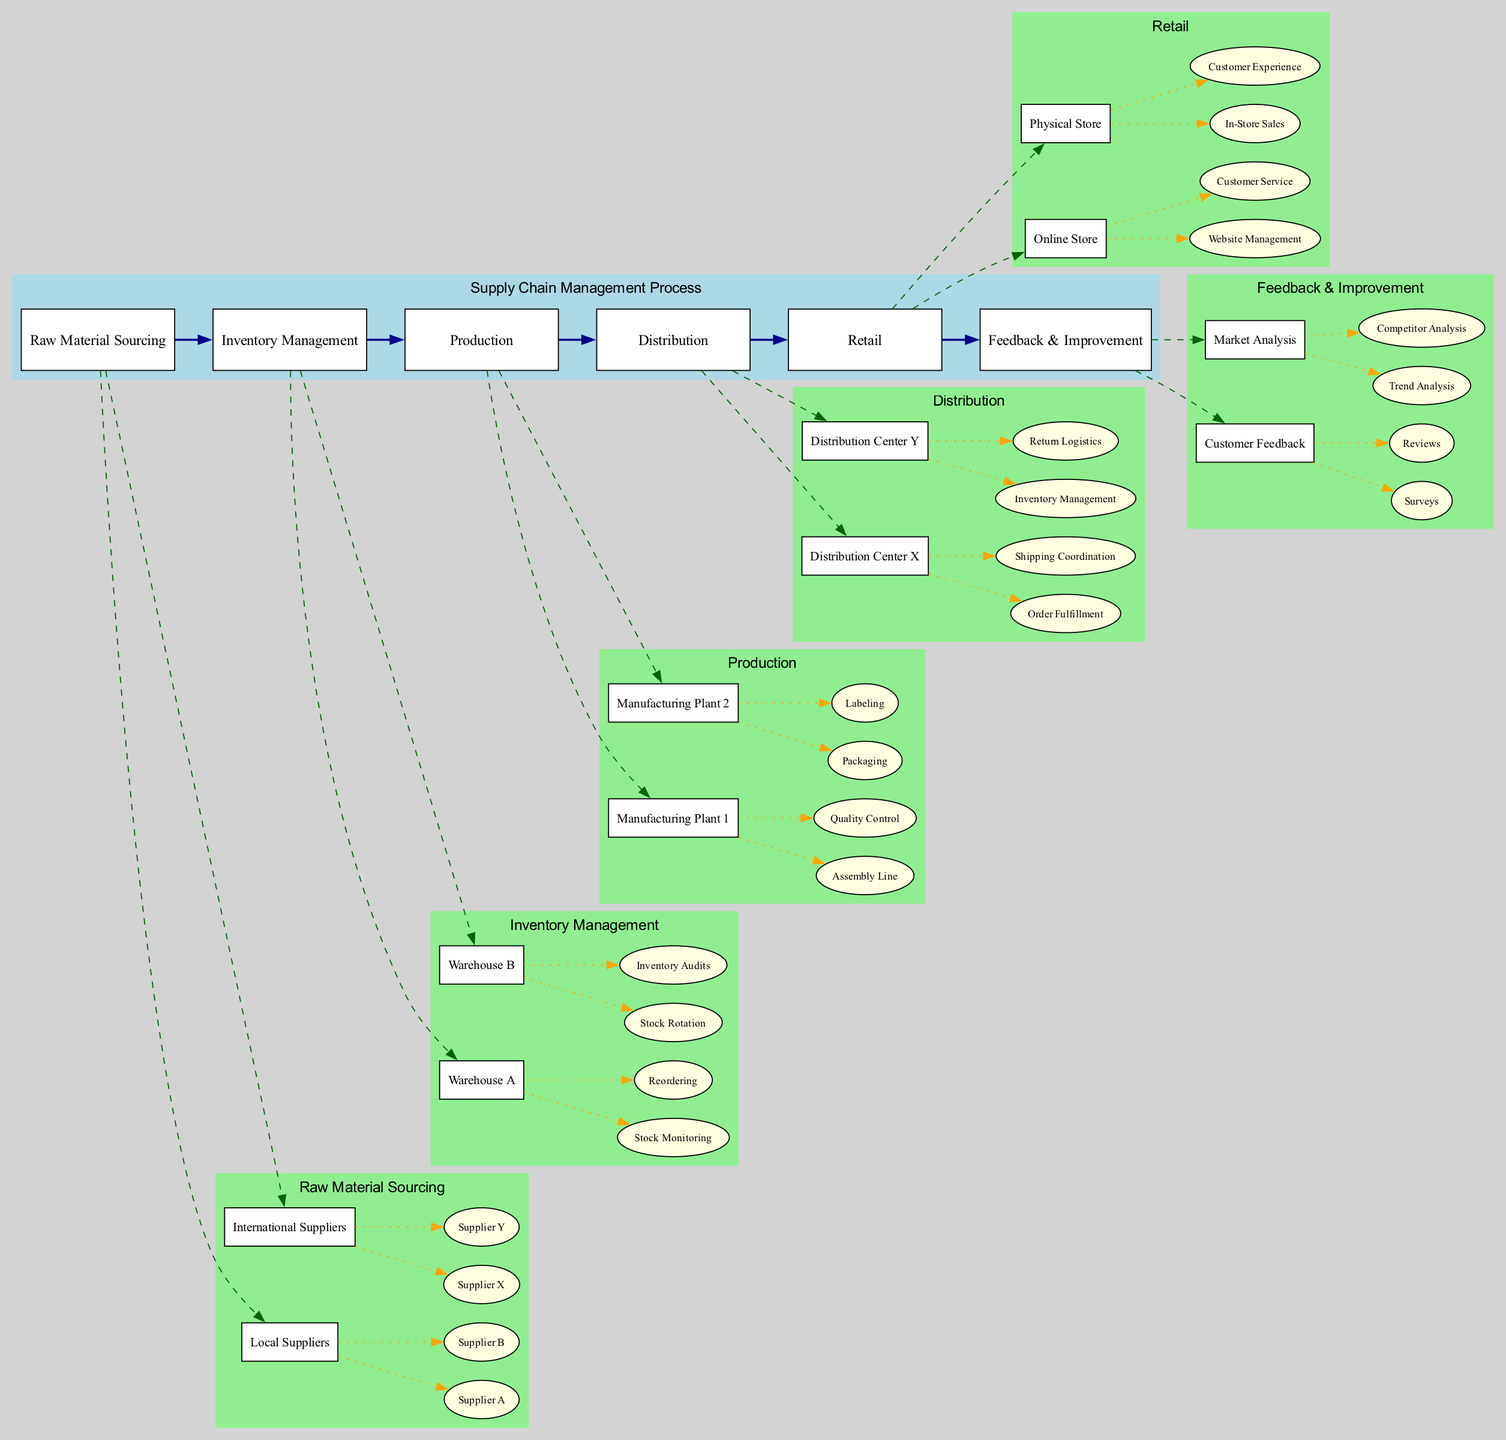How many main elements are in the supply chain management process? The diagram lists five main elements: Raw Material Sourcing, Inventory Management, Production, Distribution, and Retail. Each of these is represented as a major block in the flow.
Answer: 5 What are the sub-elements under Inventory Management? The sub-elements listed under Inventory Management are Warehouse A and Warehouse B. These two warehouses are key components shown under this element in the diagram.
Answer: Warehouse A, Warehouse B Which type of supplier is associated with Supplier A? Supplier A is categorized under Local Suppliers, which is a sub-element of the Raw Material Sourcing element. The diagram indicates that Supplier A falls into this category clearly.
Answer: Local Suppliers What are the functions of Distribution Center Y? The functions outlined for Distribution Center Y in the diagram are Inventory Management and Return Logistics. These functions are clearly marked as part of this center's responsibilities.
Answer: Inventory Management, Return Logistics What is the relationship between Production and Distribution? Production feeds into Distribution as indicated by a directed edge flowing from the Production element to the Distribution element in the diagram. This shows the process flow from creating products to distributing them.
Answer: Production to Distribution Which warehouse focuses on Stock Rotation? The diagram shows that Stock Rotation is specifically a function of Warehouse B, as it is one of the sub-elements under the Inventory Management main element.
Answer: Warehouse B How many feedback types are listed under Feedback & Improvement? There are two feedback types listed: Customer Feedback and Market Analysis, which are the sub-elements under the Feedback & Improvement main element.
Answer: 2 Which elements are related to Customer Feedback? Customer Feedback is linked to Surveys and Reviews, which are the sub-elements specifically showing the types of feedback collected in the diagram.
Answer: Surveys, Reviews What kind of suppliers are indicated in the supply chain for raw materials? The diagram indicates both Local Suppliers and International Suppliers as the categories for sourcing raw materials, highlighting the geographical scope of supply sourcing.
Answer: Local Suppliers, International Suppliers 